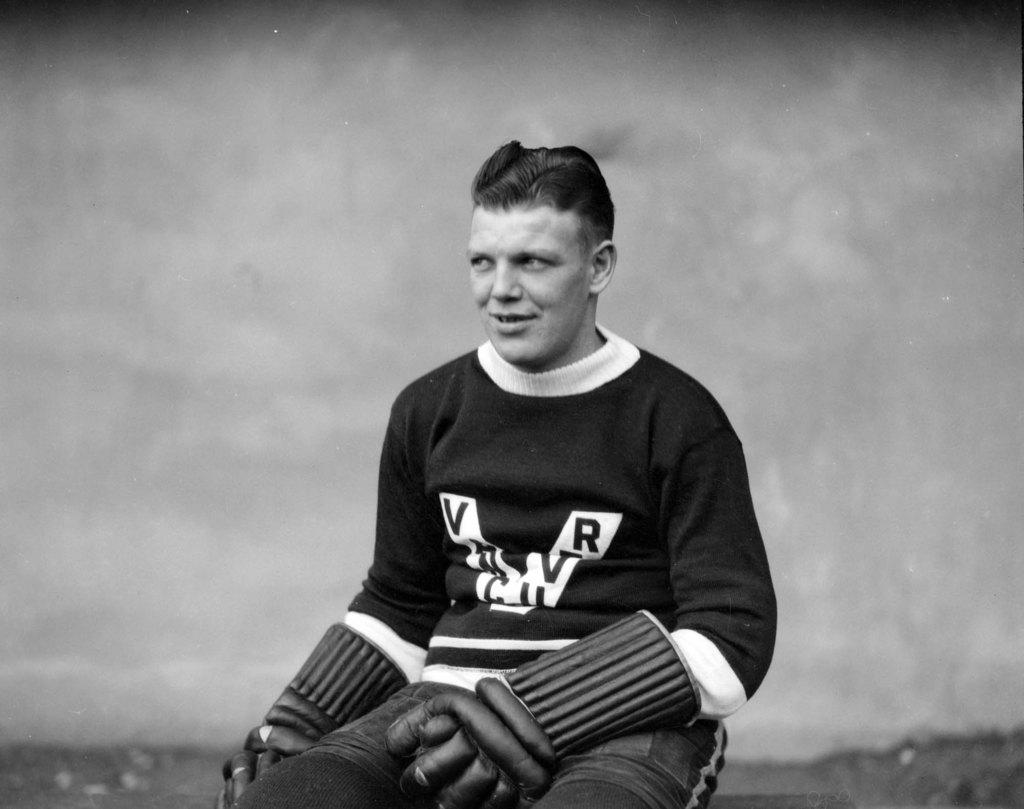<image>
Offer a succinct explanation of the picture presented. a person with a shirt on with the letters V and R on it 